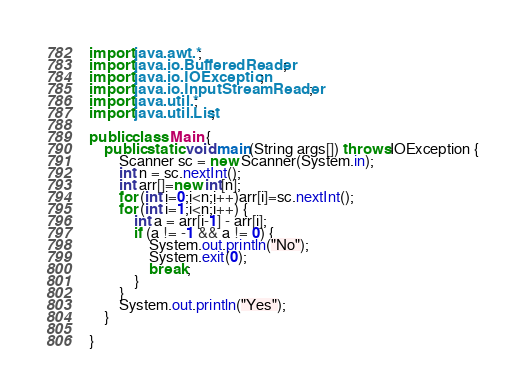Convert code to text. <code><loc_0><loc_0><loc_500><loc_500><_Java_>import java.awt.*;
import java.io.BufferedReader;
import java.io.IOException;
import java.io.InputStreamReader;
import java.util.*;
import java.util.List;

public class Main {
    public static void main(String args[]) throws IOException {
        Scanner sc = new Scanner(System.in);
        int n = sc.nextInt();
        int arr[]=new int[n];
        for (int i=0;i<n;i++)arr[i]=sc.nextInt();
        for (int i=1;i<n;i++) {
            int a = arr[i-1] - arr[i];
            if (a != -1 && a != 0) {
                System.out.println("No");
                System.exit(0);
                break;
            }
        }
        System.out.println("Yes");
    }

}

</code> 